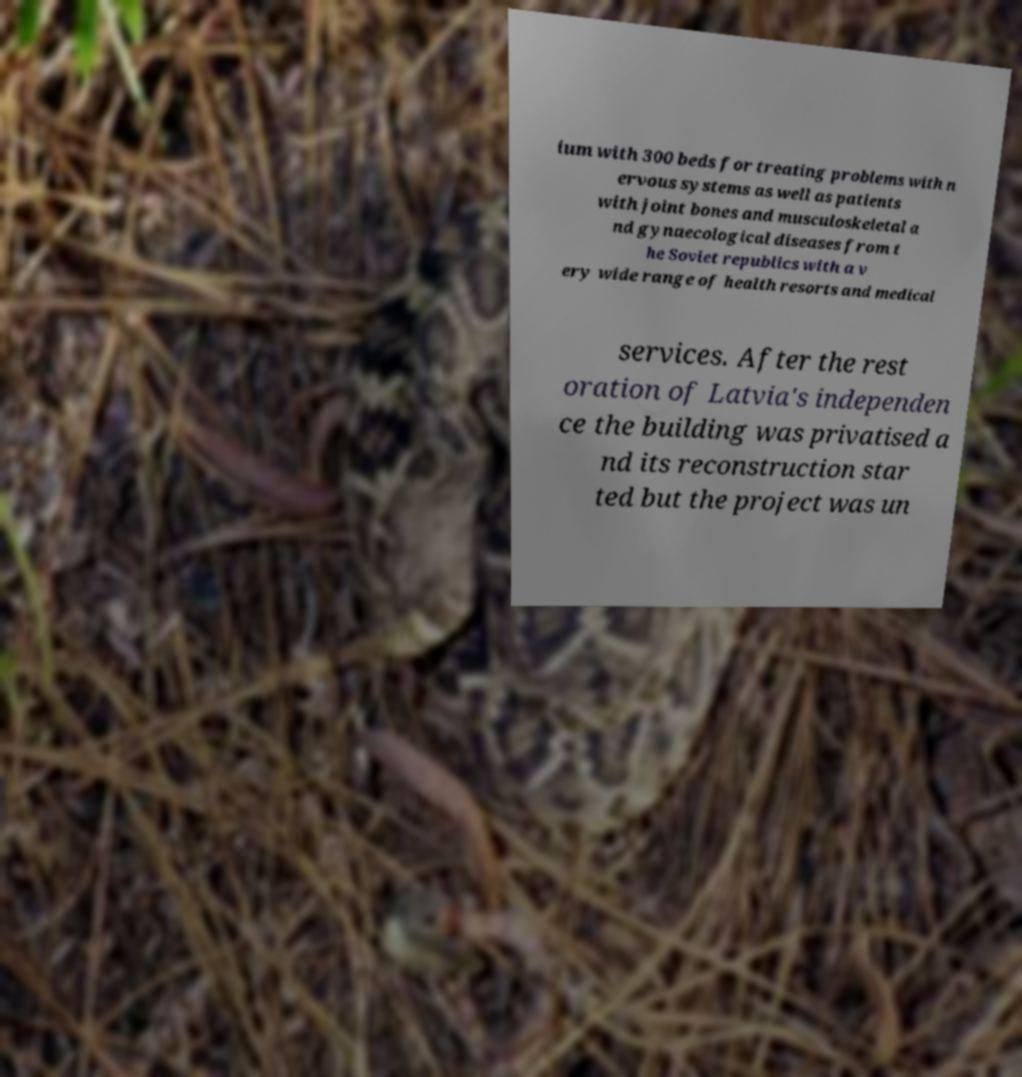There's text embedded in this image that I need extracted. Can you transcribe it verbatim? ium with 300 beds for treating problems with n ervous systems as well as patients with joint bones and musculoskeletal a nd gynaecological diseases from t he Soviet republics with a v ery wide range of health resorts and medical services. After the rest oration of Latvia's independen ce the building was privatised a nd its reconstruction star ted but the project was un 